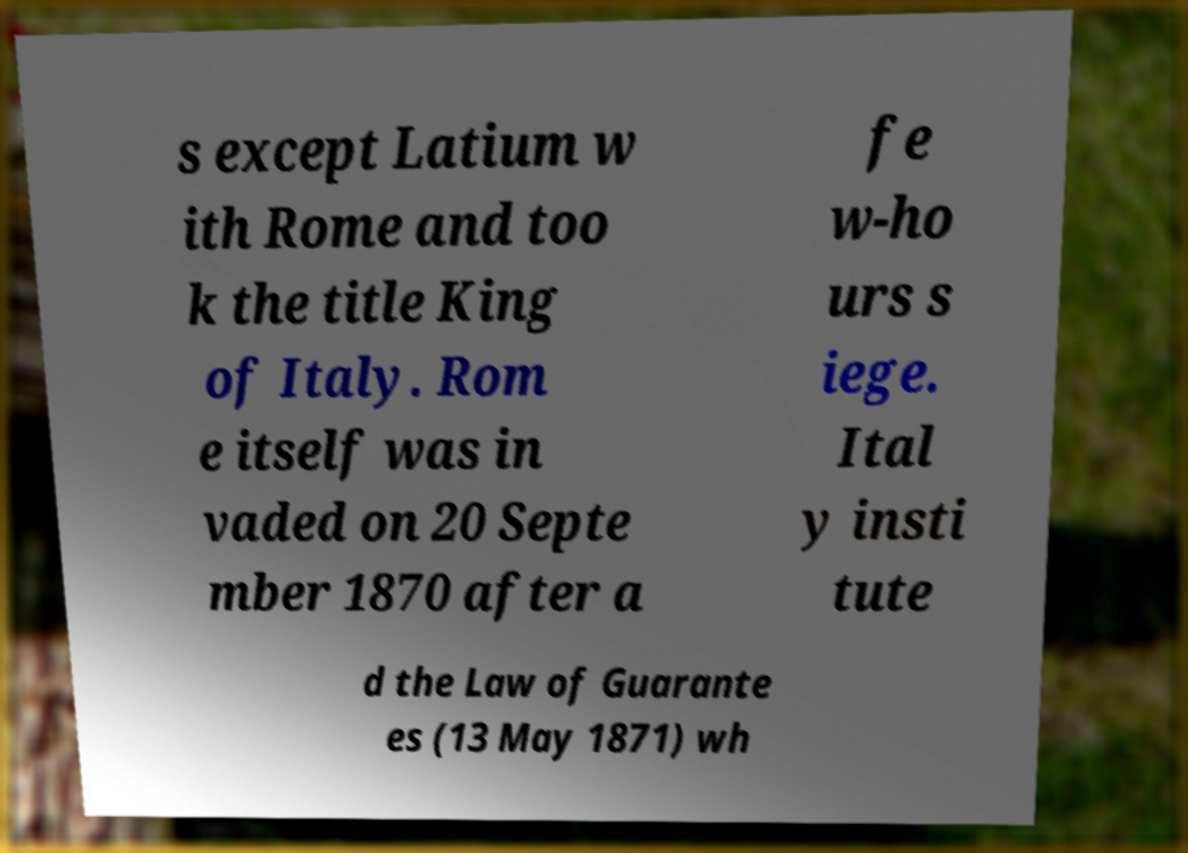Please identify and transcribe the text found in this image. s except Latium w ith Rome and too k the title King of Italy. Rom e itself was in vaded on 20 Septe mber 1870 after a fe w-ho urs s iege. Ital y insti tute d the Law of Guarante es (13 May 1871) wh 